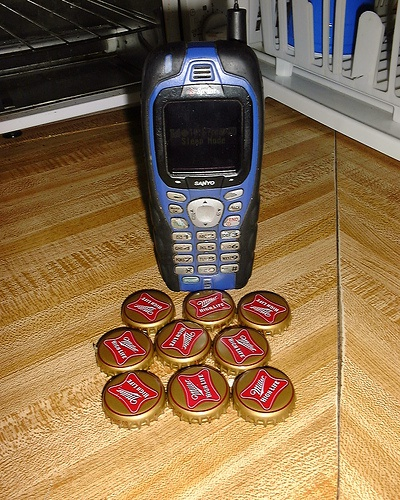Describe the objects in this image and their specific colors. I can see dining table in black, tan, olive, and khaki tones and cell phone in black, gray, and darkgray tones in this image. 